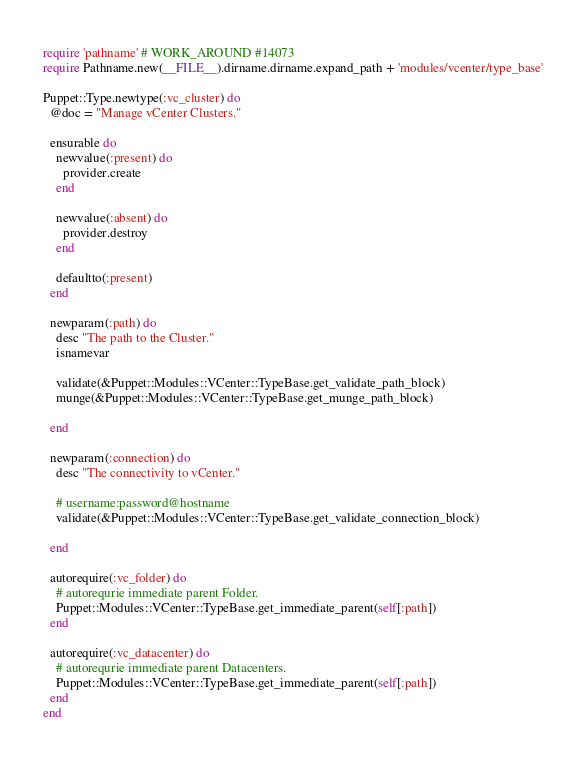<code> <loc_0><loc_0><loc_500><loc_500><_Ruby_>require 'pathname' # WORK_AROUND #14073
require Pathname.new(__FILE__).dirname.dirname.expand_path + 'modules/vcenter/type_base'

Puppet::Type.newtype(:vc_cluster) do
  @doc = "Manage vCenter Clusters."

  ensurable do
    newvalue(:present) do
      provider.create
    end

    newvalue(:absent) do
      provider.destroy
    end

    defaultto(:present)
  end

  newparam(:path) do
    desc "The path to the Cluster."
    isnamevar

    validate(&Puppet::Modules::VCenter::TypeBase.get_validate_path_block)
    munge(&Puppet::Modules::VCenter::TypeBase.get_munge_path_block)

  end

  newparam(:connection) do
    desc "The connectivity to vCenter."

    # username:password@hostname
    validate(&Puppet::Modules::VCenter::TypeBase.get_validate_connection_block)

  end

  autorequire(:vc_folder) do
    # autorequrie immediate parent Folder.
    Puppet::Modules::VCenter::TypeBase.get_immediate_parent(self[:path])
  end

  autorequire(:vc_datacenter) do
    # autorequrie immediate parent Datacenters.
    Puppet::Modules::VCenter::TypeBase.get_immediate_parent(self[:path])
  end
end

</code> 